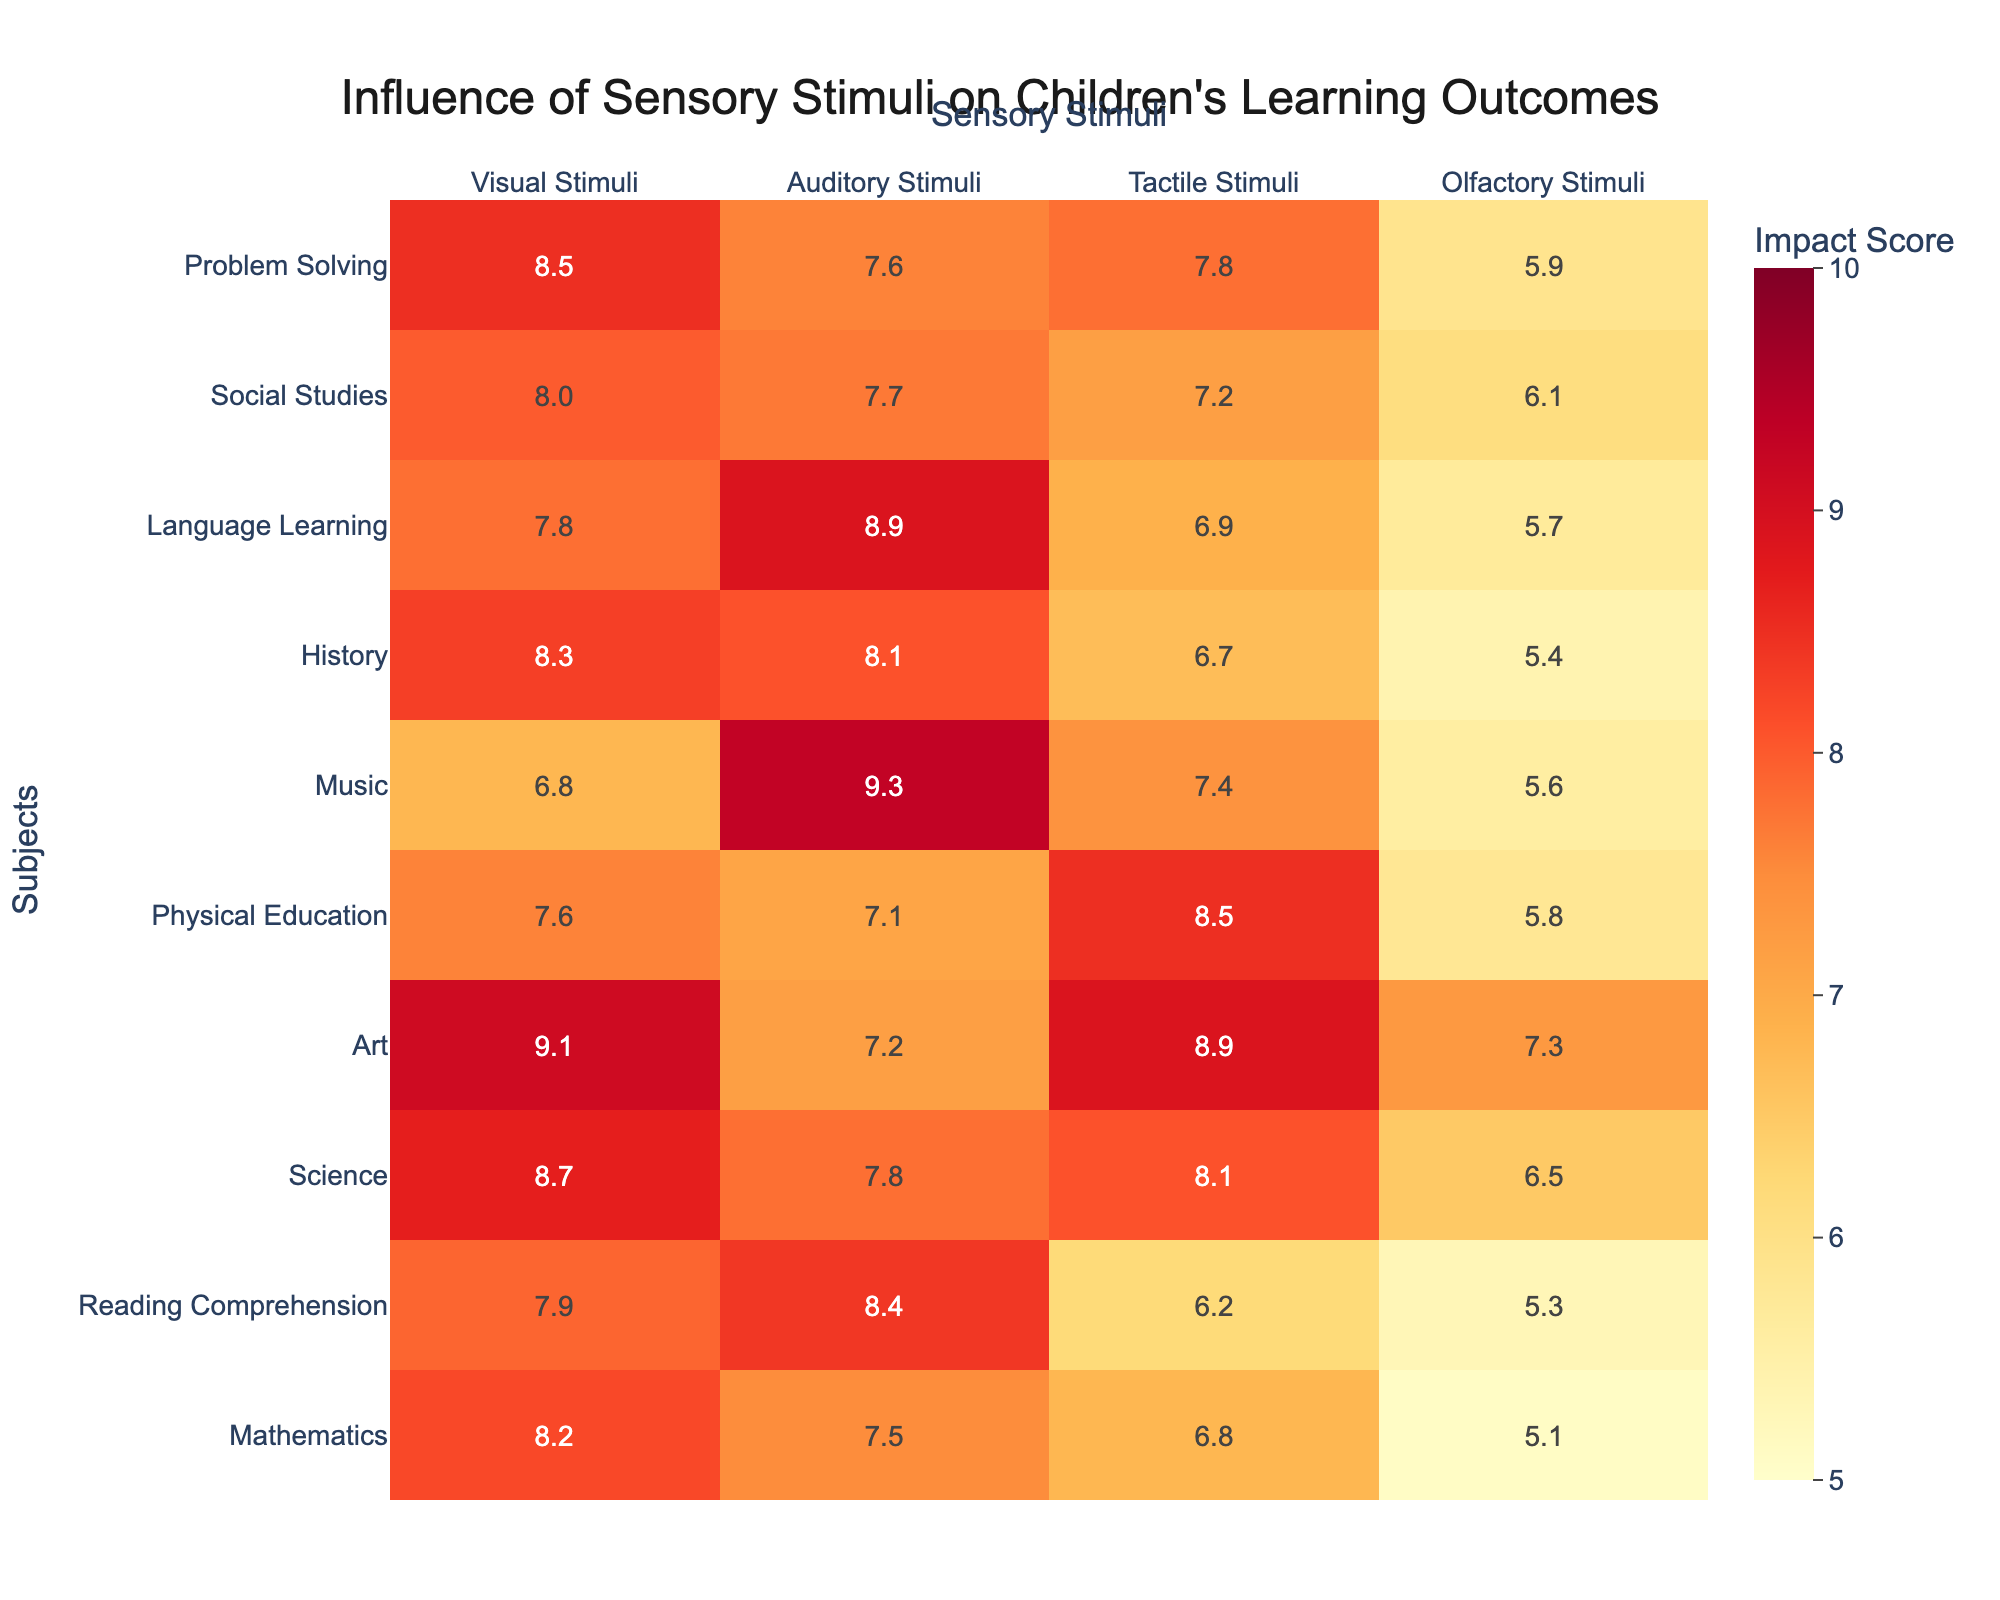What is the highest score for Visual Stimuli among all subjects? The highest score for Visual Stimuli is found in the Art subject, which has a score of 9.1.
Answer: 9.1 What is the lowest score for Tactile Stimuli in any subject? The lowest score for Tactile Stimuli is in Reading Comprehension, with a score of 6.2.
Answer: 6.2 Which subject has the highest score for Auditory Stimuli? Music has the highest score for Auditory Stimuli, with a score of 9.3.
Answer: 9.3 What is the average score for Science across all sensory stimuli? The scores for Science are: Visual 8.7, Auditory 7.8, Tactile 8.1, Olfactory 6.5. The sum is 8.7 + 7.8 + 8.1 + 6.5 = 31.1 and the average is 31.1 / 4 = 7.775.
Answer: 7.78 Is the score for Olfactory Stimuli higher in Language Learning than in Social Studies? The score for Olfactory Stimuli in Language Learning is 5.7, while in Social Studies it is 6.1. Since 5.7 is less than 6.1, the statement is false.
Answer: No For which subject is the difference between Visual and Auditory Stimuli the greatest? The differences are: Mathematics (8.2 - 7.5 = 0.7), Reading Comprehension (7.9 - 8.4 = -0.5), Science (8.7 - 7.8 = 0.9), Art (9.1 - 7.2 = 1.9), Physical Education (7.6 - 7.1 = 0.5), Music (6.8 - 9.3 = -2.5), History (8.3 - 8.1 = 0.2), Language Learning (7.8 - 8.9 = -1.1), Social Studies (8.0 - 7.7 = 0.3), and Problem Solving (8.5 - 7.6 = 0.9). The greatest difference is for Music at -2.5.
Answer: Music What are the total scores for all types of stimuli in Art and how do they compare? The scores for Art are: Visual 9.1, Auditory 7.2, Tactile 8.9, Olfactory 7.3. The total is 9.1 + 7.2 + 8.9 + 7.3 = 32.5. Comparing this to Mathematics which has a total of 8.2 + 7.5 + 6.8 + 5.1 = 27.6, Art has a higher total.
Answer: Art has a total score of 32.5, which is higher than Mathematics' total of 27.6 What is the score difference between the highest and lowest Tactile Stimuli? The highest Tactile Stimuli score is for Physical Education (8.5) and the lowest is for Reading Comprehension (6.2). The difference is 8.5 - 6.2 = 2.3.
Answer: 2.3 Which subject has the closest scores for Visual and Tactile Stimuli? The scores for Visual and Tactile Stimuli are as follows: Mathematics (8.2, 6.8), Reading Comprehension (7.9, 6.2), Science (8.7, 8.1), Art (9.1, 8.9), Physical Education (7.6, 8.5), Music (6.8, 7.4), History (8.3, 6.7), Language Learning (7.8, 6.9), Social Studies (8.0, 7.2), and Problem Solving (8.5, 7.8). Art has the closest scores (9.1 - 8.9 = 0.2).
Answer: Art Which subject has a score for Auditory Stimuli that is below the overall average for all subjects? The average of Auditory Stimuli scores is calculated as: (7.5 + 8.4 + 7.8 + 7.2 + 7.1 + 9.3 + 8.1 + 8.9 + 7.7 + 7.6) / 10 = 7.78. The subjects below this average are Mathematics (7.5), Physical Education (7.1), and Science (7.8).
Answer: Mathematics and Physical Education 